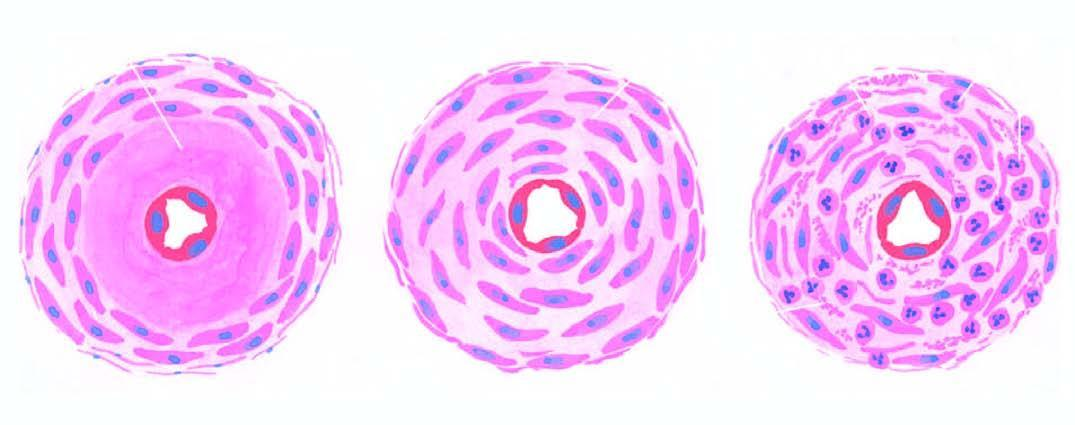what is seen in hypertension?
Answer the question using a single word or phrase. Three forms of arteriolosclerosis 